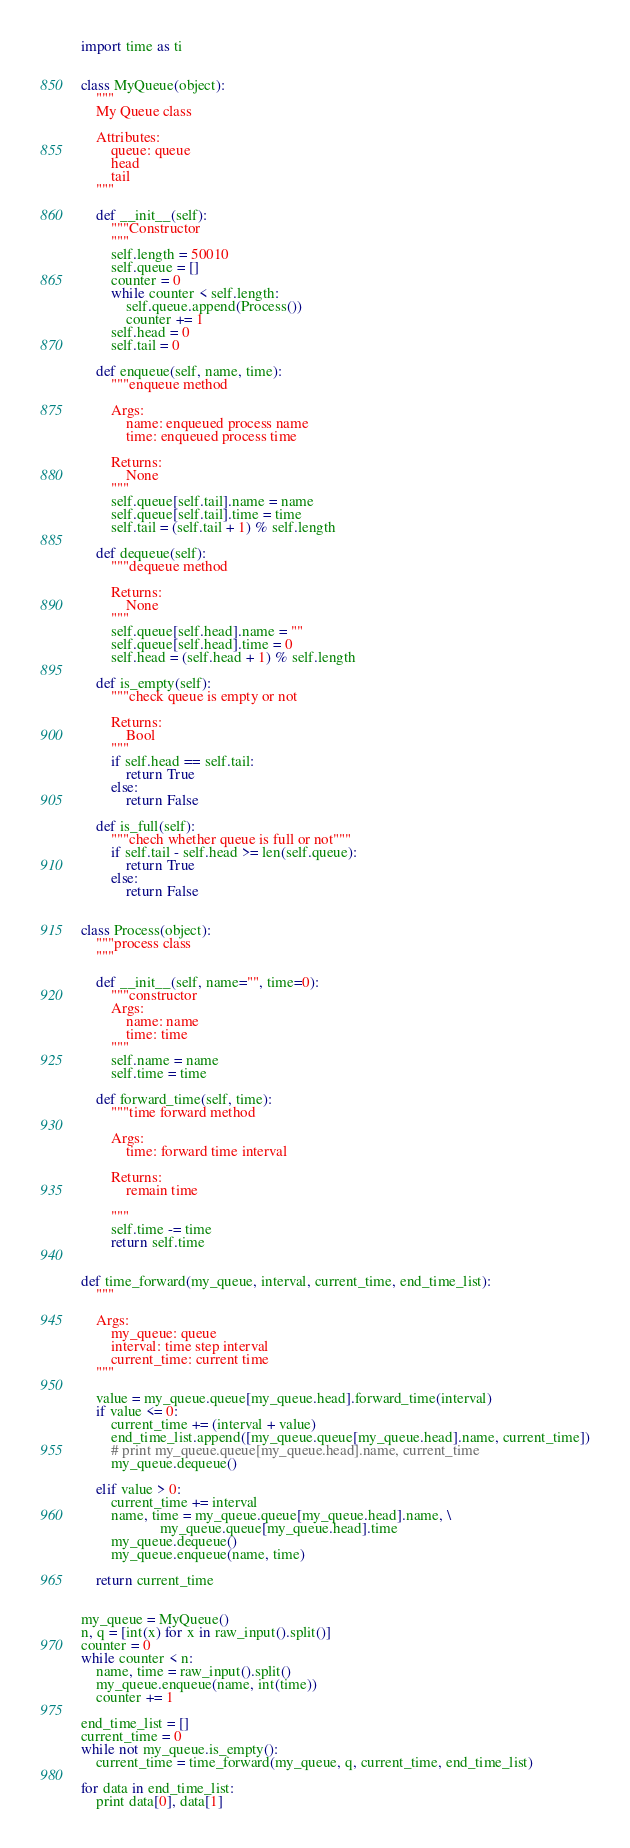<code> <loc_0><loc_0><loc_500><loc_500><_Python_>import time as ti


class MyQueue(object):
    """
    My Queue class

    Attributes:
        queue: queue
        head
        tail
    """

    def __init__(self):
        """Constructor
        """
        self.length = 50010
        self.queue = []
        counter = 0
        while counter < self.length:
            self.queue.append(Process())
            counter += 1
        self.head = 0
        self.tail = 0

    def enqueue(self, name, time):
        """enqueue method

        Args:
            name: enqueued process name
            time: enqueued process time

        Returns:
            None
        """
        self.queue[self.tail].name = name
        self.queue[self.tail].time = time
        self.tail = (self.tail + 1) % self.length

    def dequeue(self):
        """dequeue method

        Returns:
            None
        """
        self.queue[self.head].name = ""
        self.queue[self.head].time = 0
        self.head = (self.head + 1) % self.length

    def is_empty(self):
        """check queue is empty or not

        Returns:
            Bool
        """
        if self.head == self.tail:
            return True
        else:
            return False

    def is_full(self):
        """chech whether queue is full or not"""
        if self.tail - self.head >= len(self.queue):
            return True
        else:
            return False


class Process(object):
    """process class
    """

    def __init__(self, name="", time=0):
        """constructor
        Args:
            name: name
            time: time
        """
        self.name = name
        self.time = time

    def forward_time(self, time):
        """time forward method

        Args:
            time: forward time interval

        Returns:
            remain time

        """
        self.time -= time
        return self.time


def time_forward(my_queue, interval, current_time, end_time_list):
    """

    Args:
        my_queue: queue
        interval: time step interval
        current_time: current time
    """

    value = my_queue.queue[my_queue.head].forward_time(interval)
    if value <= 0:
        current_time += (interval + value)
        end_time_list.append([my_queue.queue[my_queue.head].name, current_time])
        # print my_queue.queue[my_queue.head].name, current_time
        my_queue.dequeue()

    elif value > 0:
        current_time += interval
        name, time = my_queue.queue[my_queue.head].name, \
                     my_queue.queue[my_queue.head].time
        my_queue.dequeue()
        my_queue.enqueue(name, time)

    return current_time


my_queue = MyQueue()
n, q = [int(x) for x in raw_input().split()]
counter = 0
while counter < n:
    name, time = raw_input().split()
    my_queue.enqueue(name, int(time))
    counter += 1

end_time_list = []
current_time = 0
while not my_queue.is_empty():
    current_time = time_forward(my_queue, q, current_time, end_time_list)

for data in end_time_list:
    print data[0], data[1]</code> 